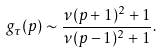<formula> <loc_0><loc_0><loc_500><loc_500>g _ { \tau } ( p ) \sim \frac { \nu ( p + 1 ) ^ { 2 } + 1 } { \nu ( p - 1 ) ^ { 2 } + 1 } .</formula> 